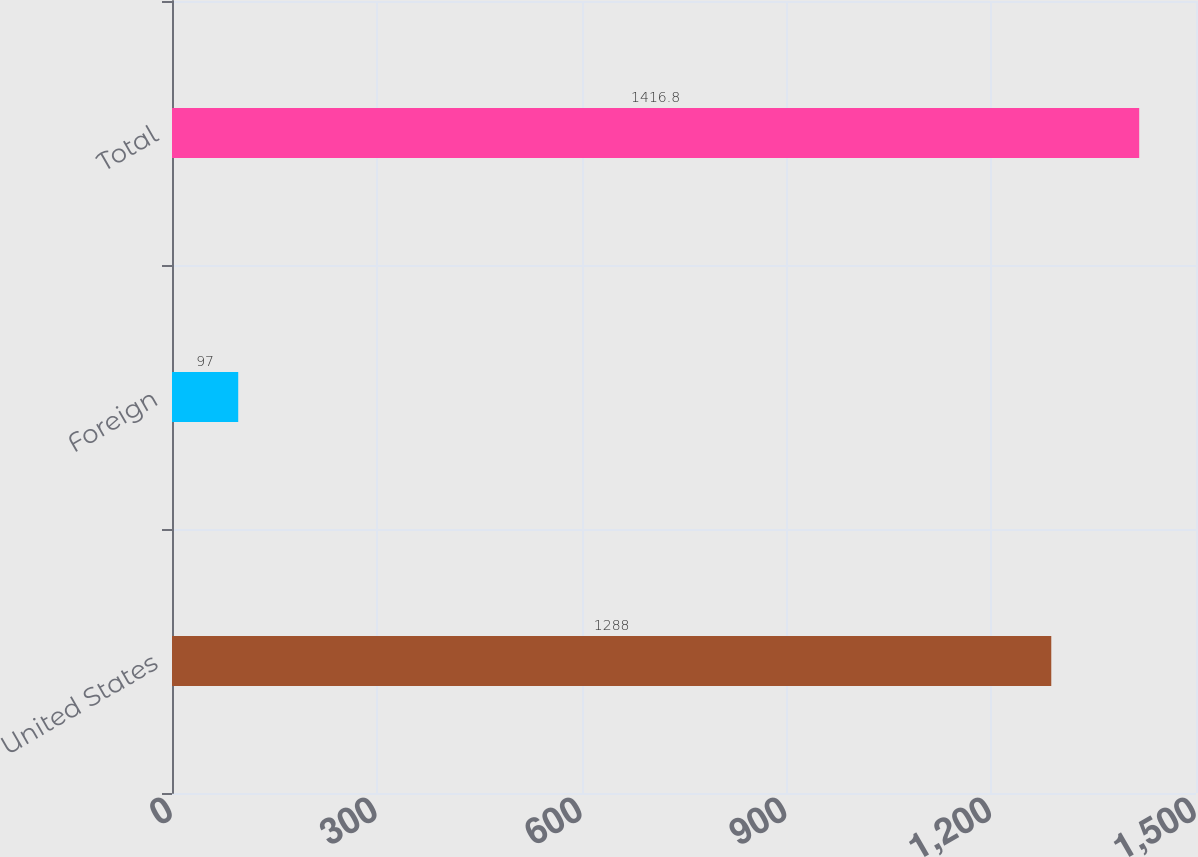Convert chart to OTSL. <chart><loc_0><loc_0><loc_500><loc_500><bar_chart><fcel>United States<fcel>Foreign<fcel>Total<nl><fcel>1288<fcel>97<fcel>1416.8<nl></chart> 